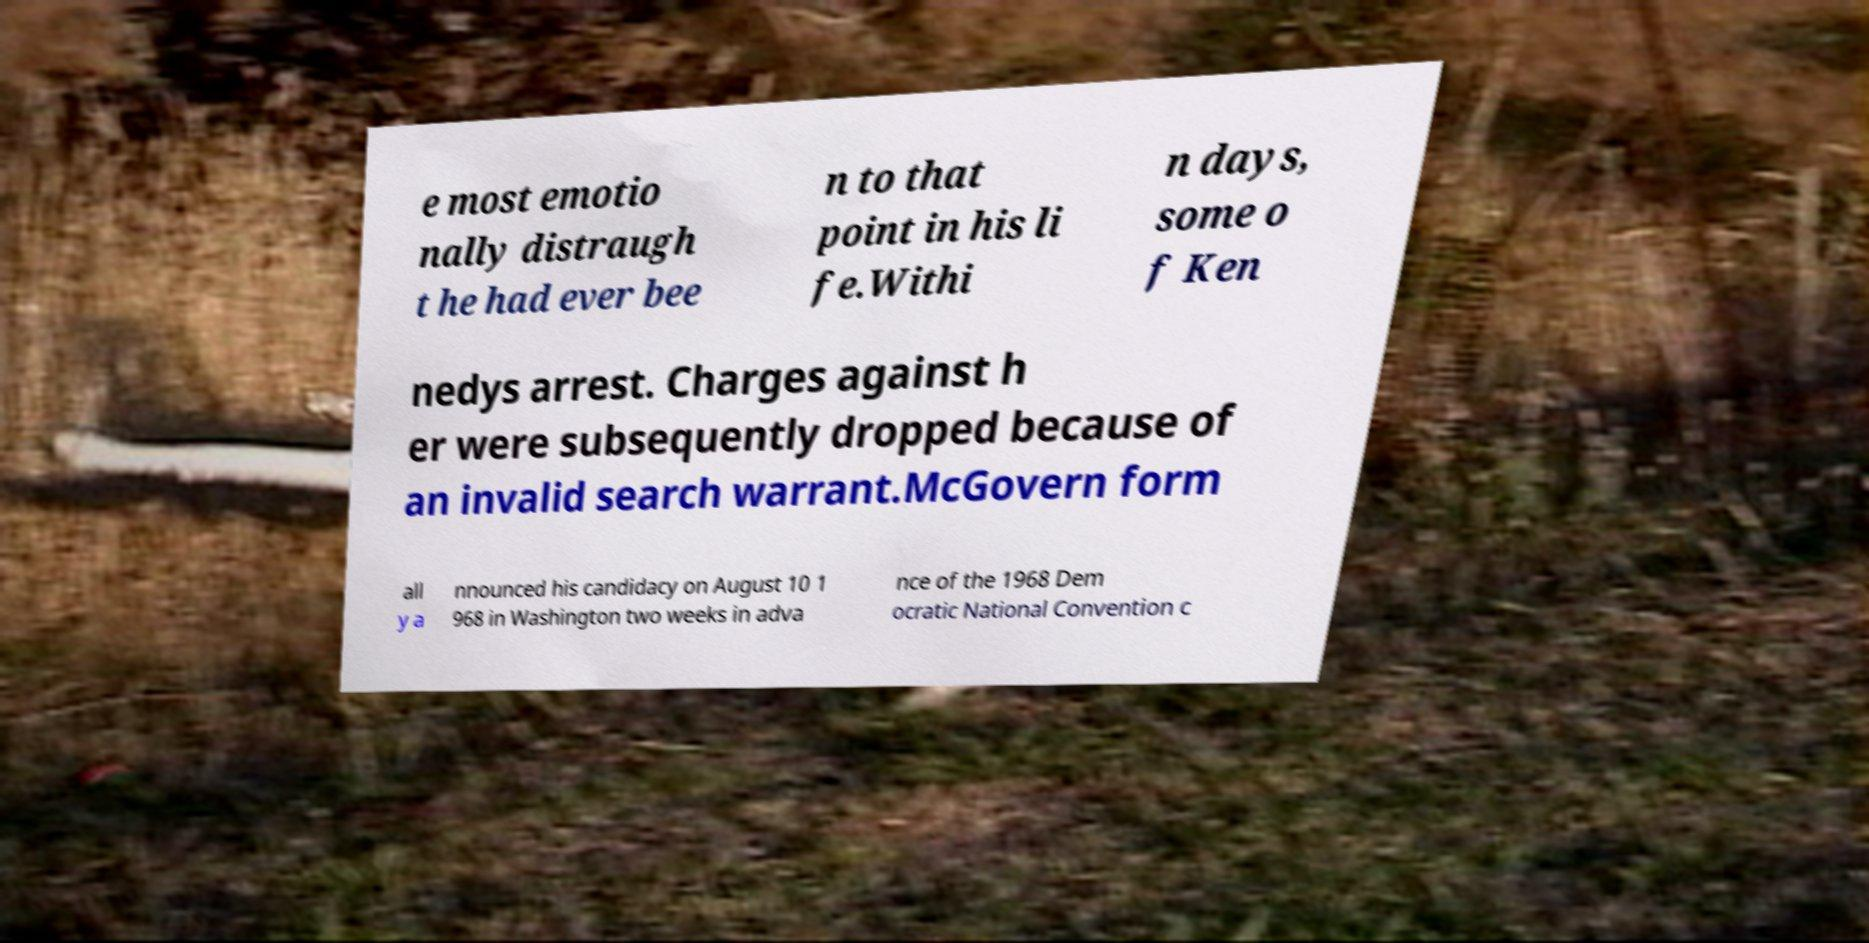There's text embedded in this image that I need extracted. Can you transcribe it verbatim? e most emotio nally distraugh t he had ever bee n to that point in his li fe.Withi n days, some o f Ken nedys arrest. Charges against h er were subsequently dropped because of an invalid search warrant.McGovern form all y a nnounced his candidacy on August 10 1 968 in Washington two weeks in adva nce of the 1968 Dem ocratic National Convention c 